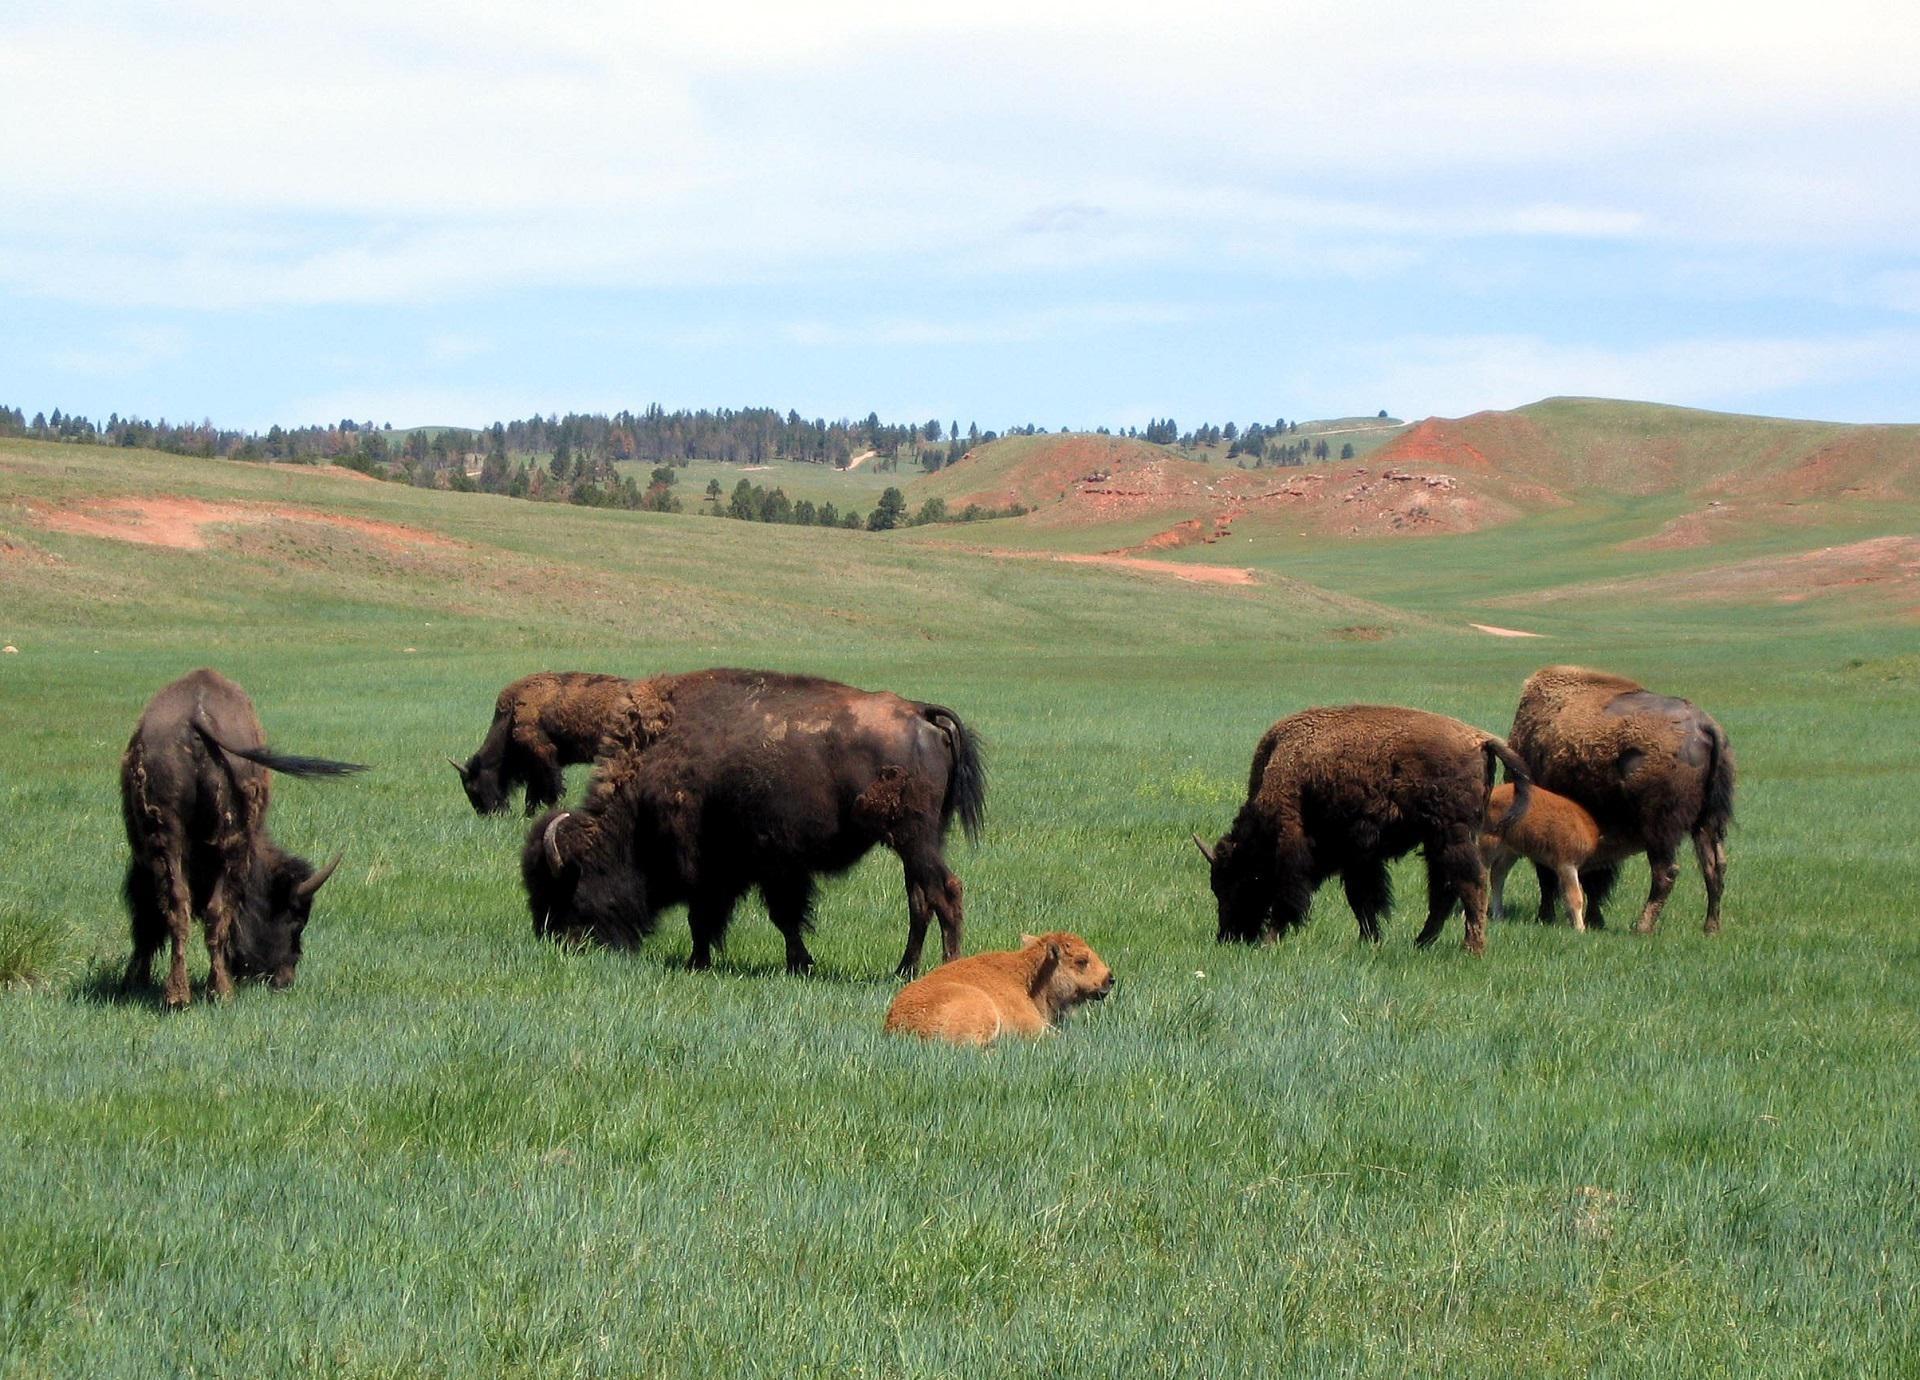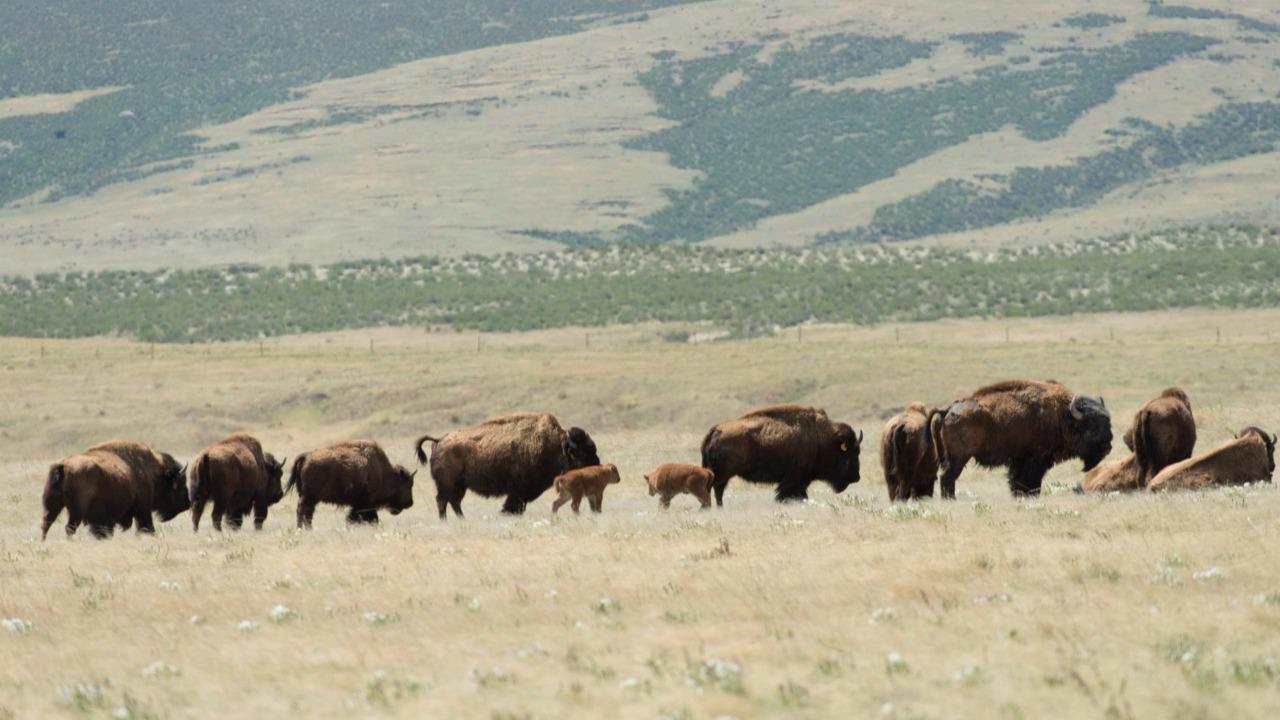The first image is the image on the left, the second image is the image on the right. Evaluate the accuracy of this statement regarding the images: "Several buffalo are standing in front of channels of water in a green field in one image.". Is it true? Answer yes or no. No. 